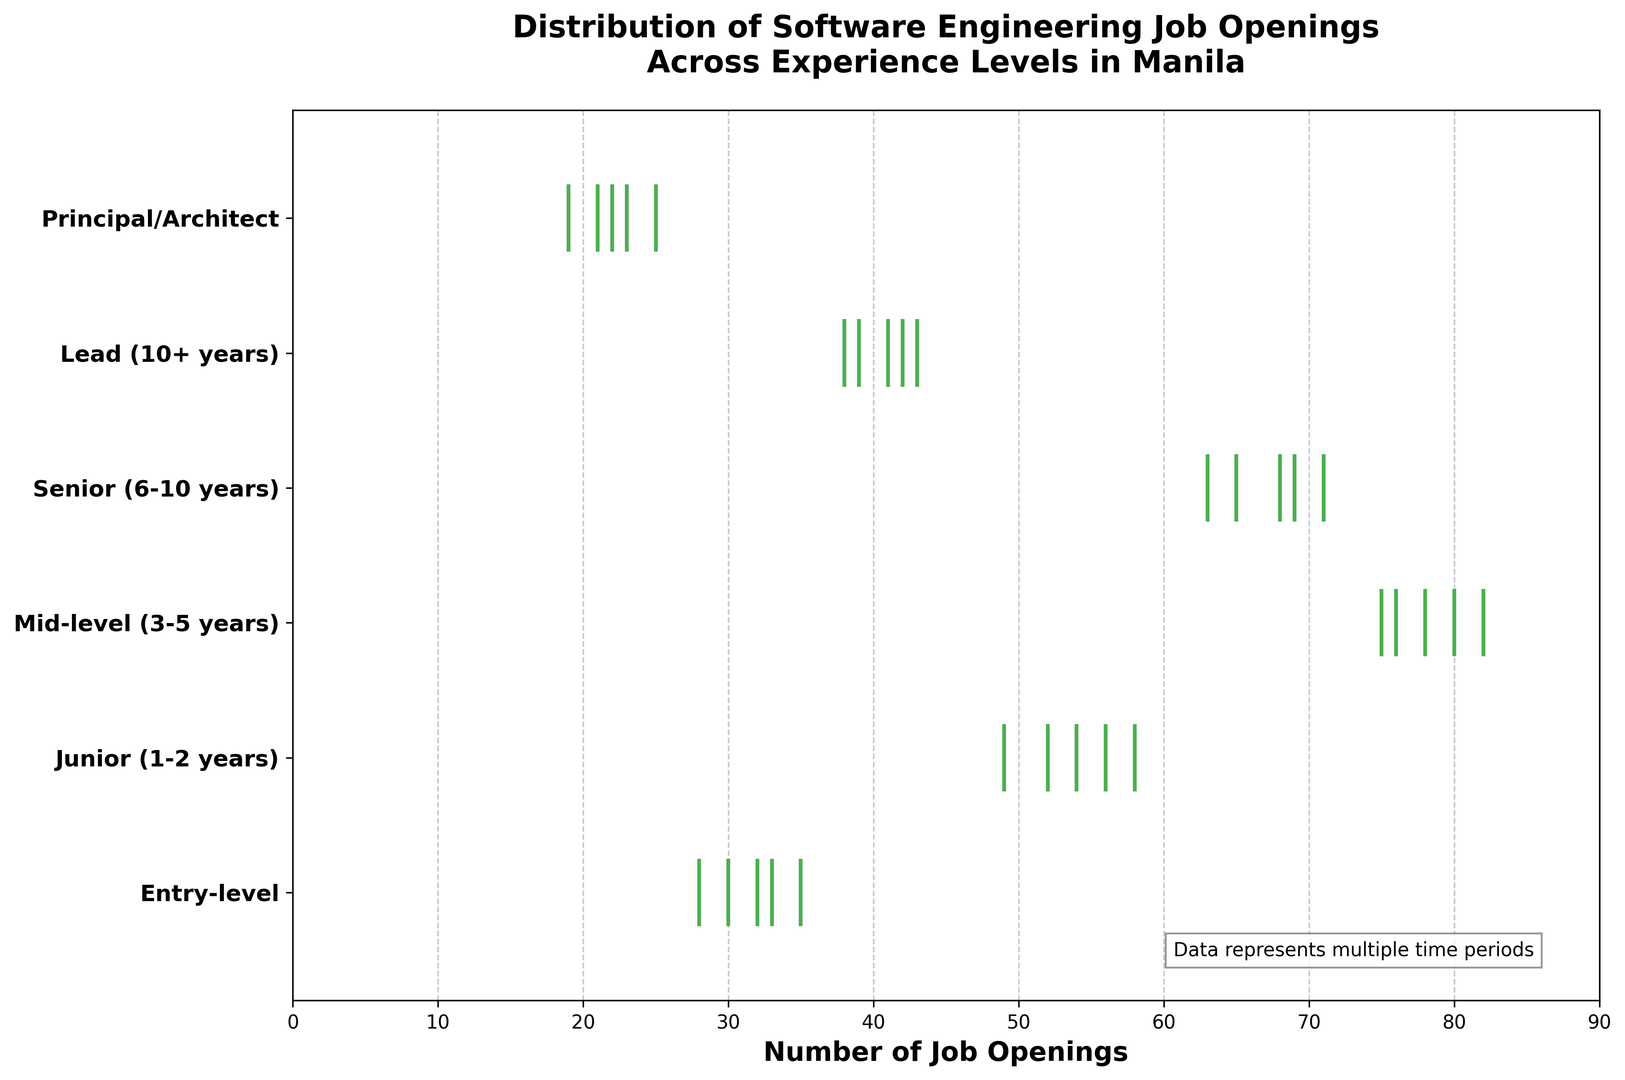Which experience level has the highest number of job openings overall? By looking at the total job openings across different periods, Mid-level has consistently high numbers. Summing up all periods for Mid-level gives 78 + 82 + 75 + 80 + 76 = 391, which is the highest among all experience levels.
Answer: Mid-level Which experience level has the lowest number of job openings overall? Summing up all periods for Principal/Architect gives 23 + 19 + 21 + 25 + 22 = 110. This is the lowest sum among all experience levels.
Answer: Principal/Architect What's the average number of job openings for Entry-level positions? Summing up all job openings for Entry-level positions and dividing by the number of periods: (32 + 28 + 35 + 30 + 33)/5 = 31.6.
Answer: 31.6 How do job openings for Senior (6-10 years) compare to Lead (10+ years)? Summing up both over the periods, Senior has 65 + 71 + 68 + 63 + 69 = 336 and Lead has 41 + 38 + 43 + 39 + 42 = 203. The job openings for Senior are higher.
Answer: Senior (6-10 years) Which experience levels show the most and least variability in job openings across the periods? By visually examining the spread of the events, Mid-level shows consistent high counts with little variability, while Entry-level shows more fluctuation and lower counts in some periods.
Answer: Most: Entry-level; Least: Mid-level What's the median number of job openings for Lead (10+ years)? Sorting the numbers 41, 38, 43, 39, 42 for Lead and finding the middle value gives us 41.
Answer: 41 Which experience level has more job openings: Junior (1-2 years) or Senior (6-10 years)? Summing up both over the periods: Junior has 54 + 49 + 58 + 52 + 56 = 269; Senior has 65 + 71 + 68 + 63 + 69 = 336. Senior has more job openings.
Answer: Senior (6-10 years) Are job openings for Mid-level positions generally increasing, decreasing, or stable over the periods? The job openings for Mid-level across various periods are 78, 82, 75, 80, and 76, which generally appear stable with minor variations.
Answer: Stable What's the total number of job openings for Principal/Architect positions over the given periods? Adding up all values for Principal/Architect positions: 23 + 19 + 21 + 25 + 22 = 110.
Answer: 110 